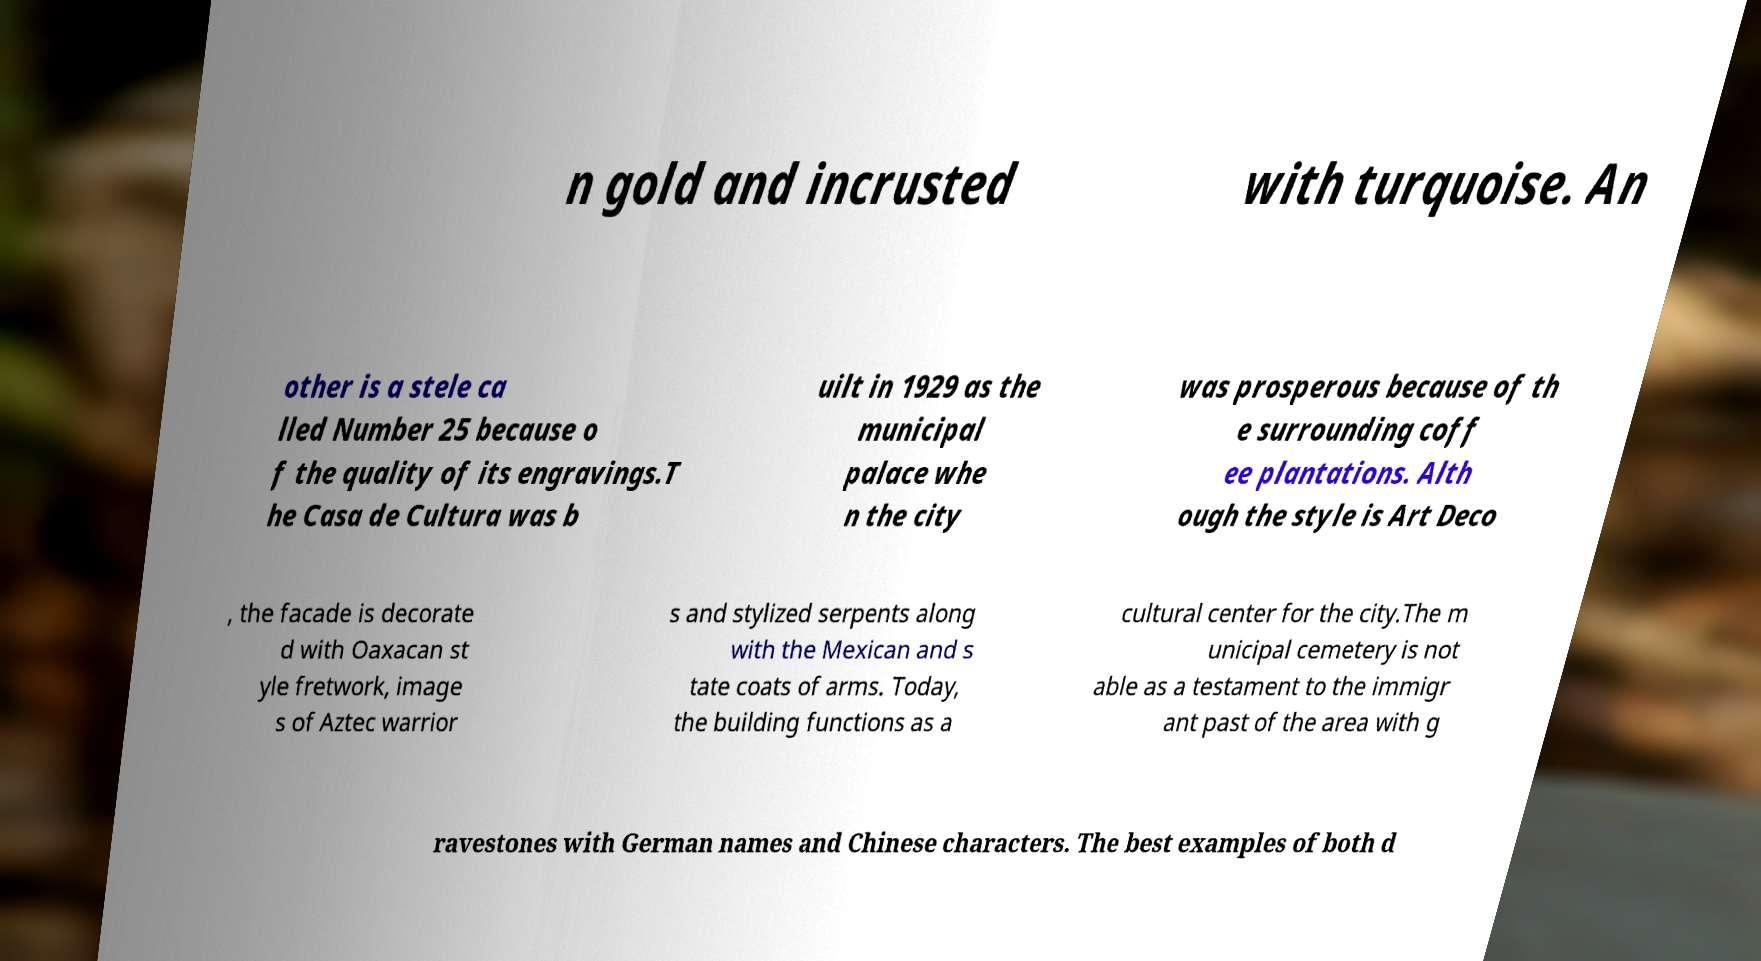Can you accurately transcribe the text from the provided image for me? n gold and incrusted with turquoise. An other is a stele ca lled Number 25 because o f the quality of its engravings.T he Casa de Cultura was b uilt in 1929 as the municipal palace whe n the city was prosperous because of th e surrounding coff ee plantations. Alth ough the style is Art Deco , the facade is decorate d with Oaxacan st yle fretwork, image s of Aztec warrior s and stylized serpents along with the Mexican and s tate coats of arms. Today, the building functions as a cultural center for the city.The m unicipal cemetery is not able as a testament to the immigr ant past of the area with g ravestones with German names and Chinese characters. The best examples of both d 